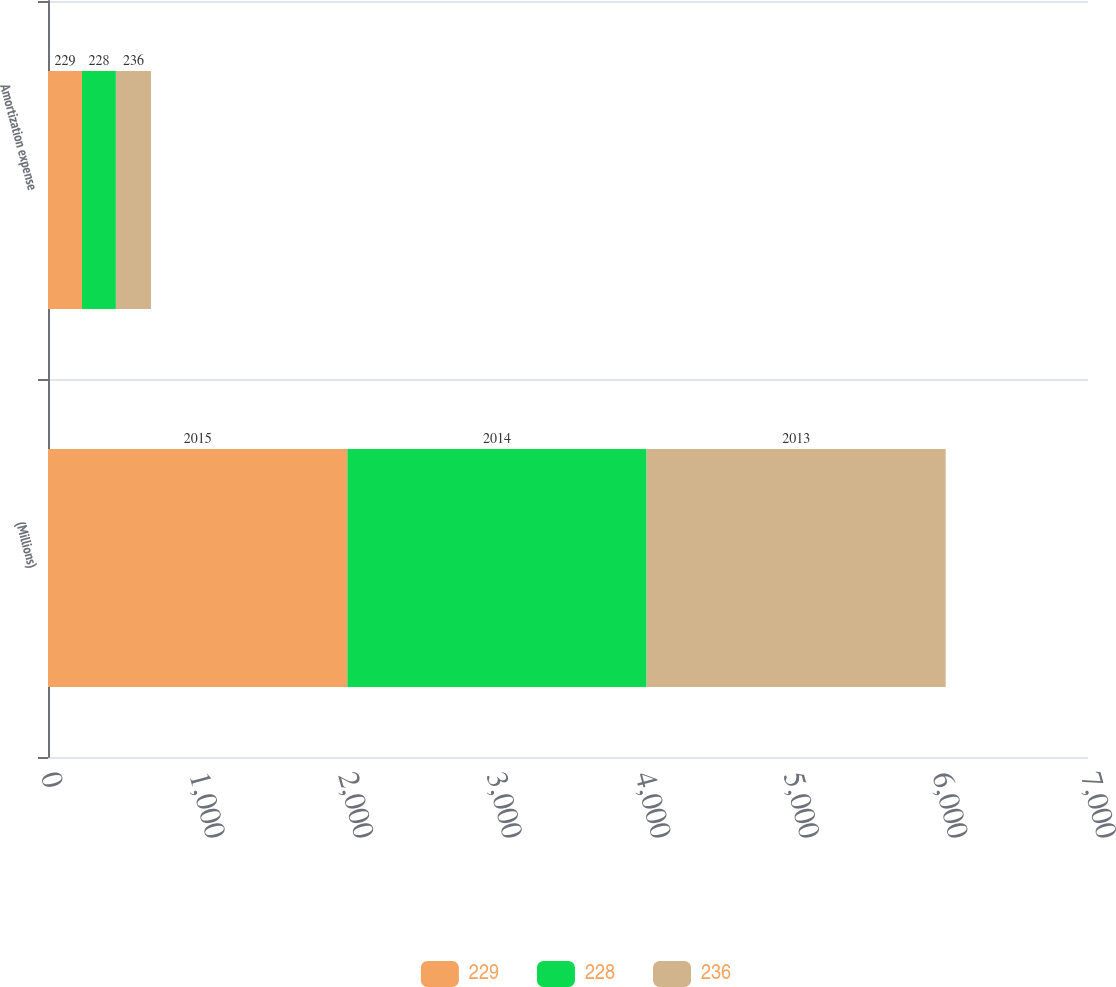Convert chart to OTSL. <chart><loc_0><loc_0><loc_500><loc_500><stacked_bar_chart><ecel><fcel>(Millions)<fcel>Amortization expense<nl><fcel>229<fcel>2015<fcel>229<nl><fcel>228<fcel>2014<fcel>228<nl><fcel>236<fcel>2013<fcel>236<nl></chart> 